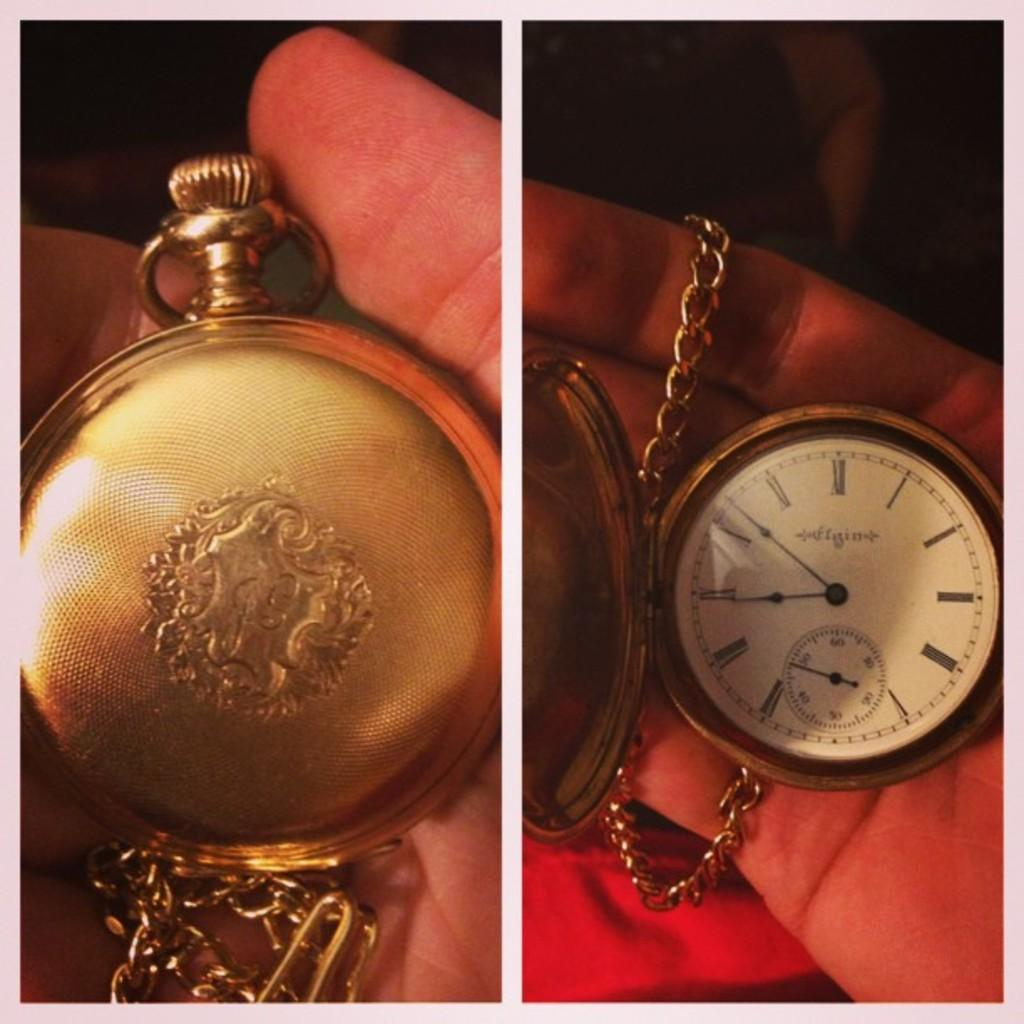<image>
Share a concise interpretation of the image provided. a pocket watch is open and displays  the time as just after ten to nine. 